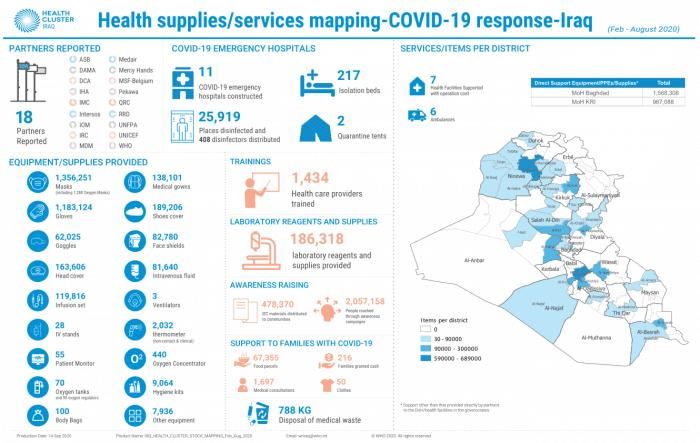Outline some significant characteristics in this image. Thirteen ventilators were provided in total. There are currently two quarantine tents in use. The total count of TV stands and Body Bags provided is 128. The training of health care trainers has resulted in the successful deployment of 1,434 trained professionals. In total, 67,355 food parcels have been provided. 